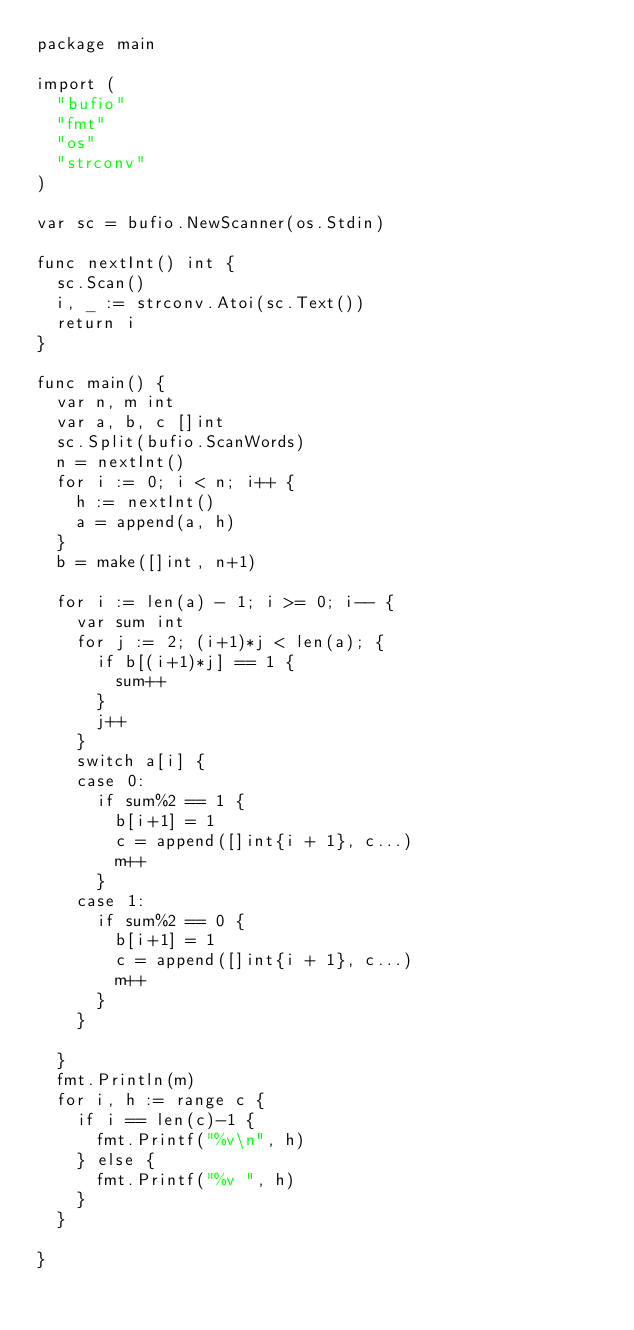<code> <loc_0><loc_0><loc_500><loc_500><_Go_>package main

import (
	"bufio"
	"fmt"
	"os"
	"strconv"
)

var sc = bufio.NewScanner(os.Stdin)

func nextInt() int {
	sc.Scan()
	i, _ := strconv.Atoi(sc.Text())
	return i
}

func main() {
	var n, m int
	var a, b, c []int
	sc.Split(bufio.ScanWords)
	n = nextInt()
	for i := 0; i < n; i++ {
		h := nextInt()
		a = append(a, h)
	}
	b = make([]int, n+1)

	for i := len(a) - 1; i >= 0; i-- {
		var sum int
		for j := 2; (i+1)*j < len(a); {
			if b[(i+1)*j] == 1 {
				sum++
			}
			j++
		}
		switch a[i] {
		case 0:
			if sum%2 == 1 {
				b[i+1] = 1
				c = append([]int{i + 1}, c...)
				m++
			}
		case 1:
			if sum%2 == 0 {
				b[i+1] = 1
				c = append([]int{i + 1}, c...)
				m++
			}
		}

	}
	fmt.Println(m)
	for i, h := range c {
		if i == len(c)-1 {
			fmt.Printf("%v\n", h)
		} else {
			fmt.Printf("%v ", h)
		}
	}

}
</code> 